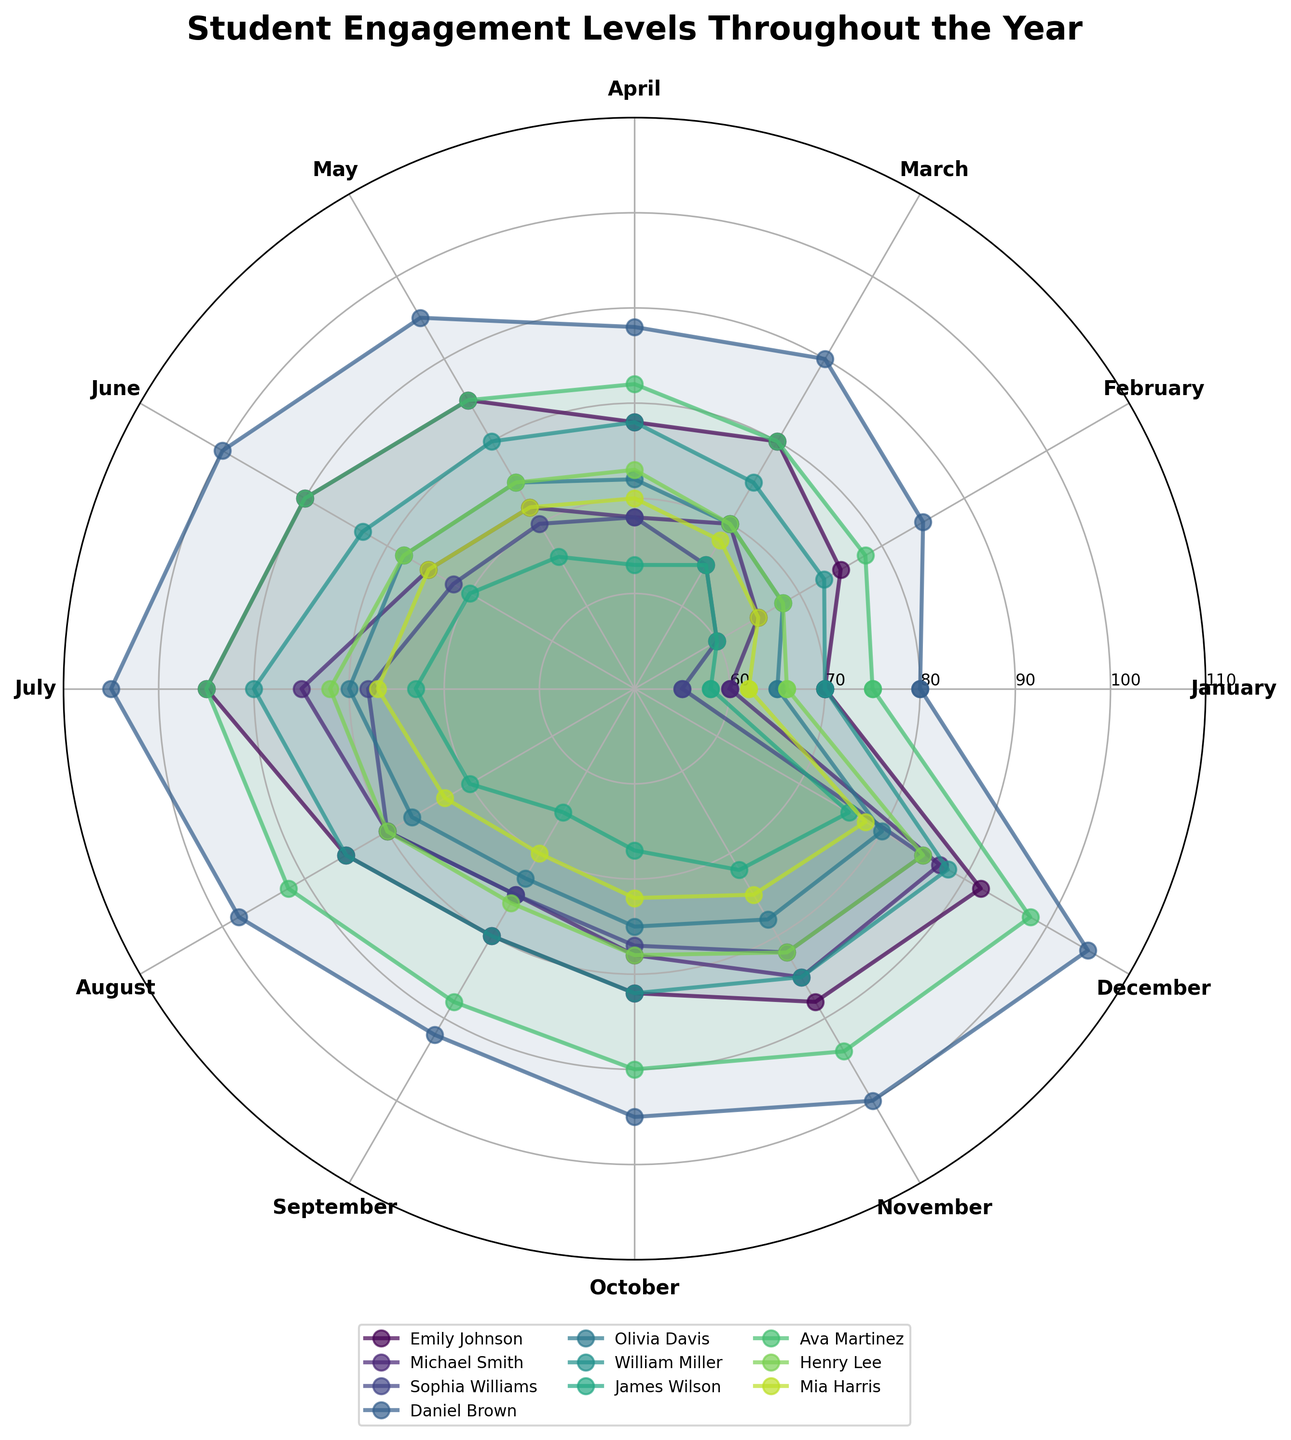What is the title of the polar chart? The title of the polar chart is written at the top and usually summarizes the main topic of the figure.
Answer: Student Engagement Levels Throughout the Year What is the engagement level of Daniel Brown in July? To find Daniel Brown's engagement level in July, follow his data plot to the July marker position.
Answer: 105 Which student has the highest engagement level in June? Look at the engagement levels for all students at the June marker position and identify the highest value.
Answer: Daniel Brown What is the average engagement level for Emily Johnson in the first three months? Add Emily Johnson's engagement levels for January (70), February (75), and March (80) and then divide by 3. 70 + 75 + 80 = 225, 225 / 3 = 75
Answer: 75 How does Sophia Williams' engagement level in September compare to her engagement level in December? Locate Sophia Williams' engagement level in September (75) and December (85). Then compare the two values.
Answer: December is higher Which student shows the most significant improvement from January to December? Calculate the difference between December and January for each student and find the largest difference. Daniel Brown: 105-80=25, Olivia Davis: 80-65=15, etc. Daniel Brown has the highest improvement of 25.
Answer: Daniel Brown How does Michael Smith's engagement level in April compare to Mia Harris' engagement level in April? Check Michael Smith's engagement level in April (68) and Mia Harris' engagement level in April (70) and then compare these values.
Answer: Mia Harris is higher What is the pattern of Ava Martinez's engagement throughout the year? Observe Ava Martinez's engagement levels month by month, specifically noting the overall trend and any significant changes. Ava starts at 75 in January and generally increases to 98 in December.
Answer: Increasing trend Which month generally shows the highest engagement levels across all students? Analyze the chart to identify which month has the highest average engagement level for most students. July and December have very high values for most students.
Answer: July or December (both have high levels) What is the median engagement level for William Miller over the entire year? List out William Miller's engagement levels for all 12 months, sort them, and find the median value. His values are 70, 73, 75, 78, 80, 82, 83, 85, 85, 88, 90. The middle two values are 80 and 82, so the median is (80 + 82) / 2 = 81
Answer: 81 